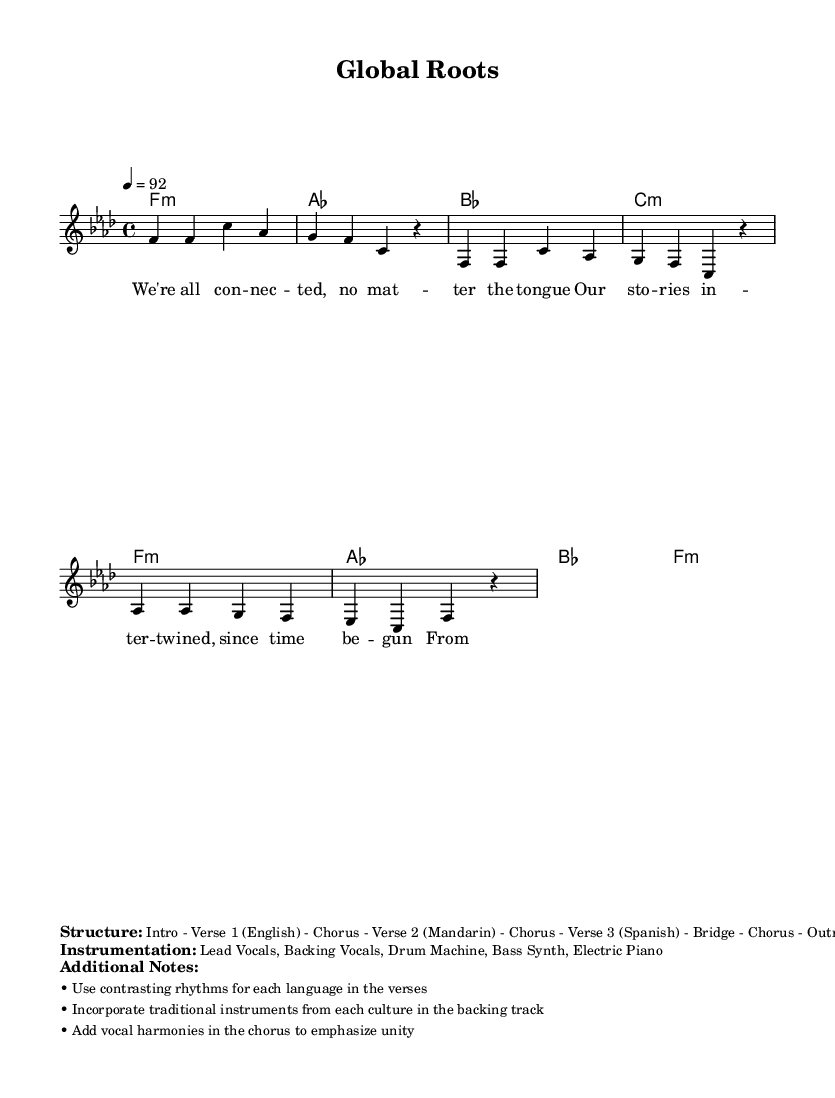What is the key signature of this music? The key signature is F minor, indicated by the presence of four flats.
Answer: F minor What is the time signature of the piece? The time signature specified is 4/4, which means there are four beats in a measure.
Answer: 4/4 What is the tempo of the piece? The tempo is marked at 92 beats per minute, indicating the speed of the music.
Answer: 92 How many verses are there in the structure? The structure includes three verses, each performed in a different language (English, Mandarin, Spanish).
Answer: Three What unique instrumentation is mentioned in the piece? The instrumentation includes Lead Vocals, Backing Vocals, Drum Machine, Bass Synth, and Electric Piano, highlighting a blend of traditional and modern elements typical in rap music.
Answer: Lead Vocals, Backing Vocals, Drum Machine, Bass Synth, Electric Piano What thematic elements are explored through the lyrics? The lyrics focus on unity and connectedness despite language barriers, reflecting diverse identities and heritage, which is a common theme in multilingual rap collaborations.
Answer: Unity and Identity 